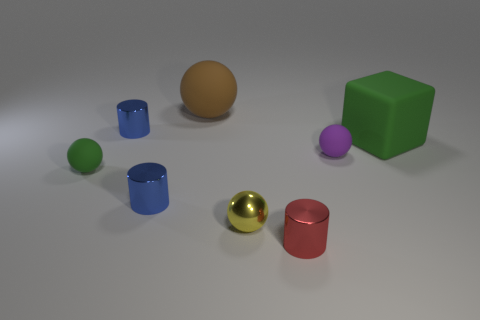What number of objects are either small yellow metal blocks or big green rubber things?
Provide a short and direct response. 1. There is a small shiny object that is in front of the big green thing and to the left of the large brown matte thing; what is its shape?
Your answer should be very brief. Cylinder. How many small metallic cylinders are there?
Offer a terse response. 3. There is a small sphere that is the same material as the small red cylinder; what is its color?
Your answer should be very brief. Yellow. Are there more small cyan metallic cubes than red things?
Ensure brevity in your answer.  No. What size is the thing that is in front of the tiny green object and right of the yellow thing?
Your answer should be very brief. Small. There is a object that is the same color as the big block; what is it made of?
Offer a terse response. Rubber. Are there the same number of small green rubber spheres that are on the left side of the yellow metal sphere and purple matte objects?
Your answer should be very brief. Yes. Is the purple rubber thing the same size as the red metallic thing?
Give a very brief answer. Yes. There is a rubber ball that is left of the small red shiny object and in front of the large brown rubber ball; what is its color?
Give a very brief answer. Green. 